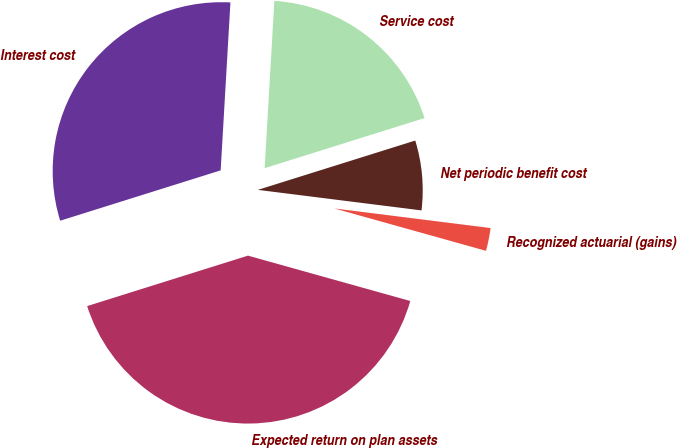<chart> <loc_0><loc_0><loc_500><loc_500><pie_chart><fcel>Service cost<fcel>Interest cost<fcel>Expected return on plan assets<fcel>Recognized actuarial (gains)<fcel>Net periodic benefit cost<nl><fcel>19.24%<fcel>30.76%<fcel>40.82%<fcel>2.35%<fcel>6.82%<nl></chart> 